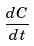Convert formula to latex. <formula><loc_0><loc_0><loc_500><loc_500>\frac { d C } { d t }</formula> 